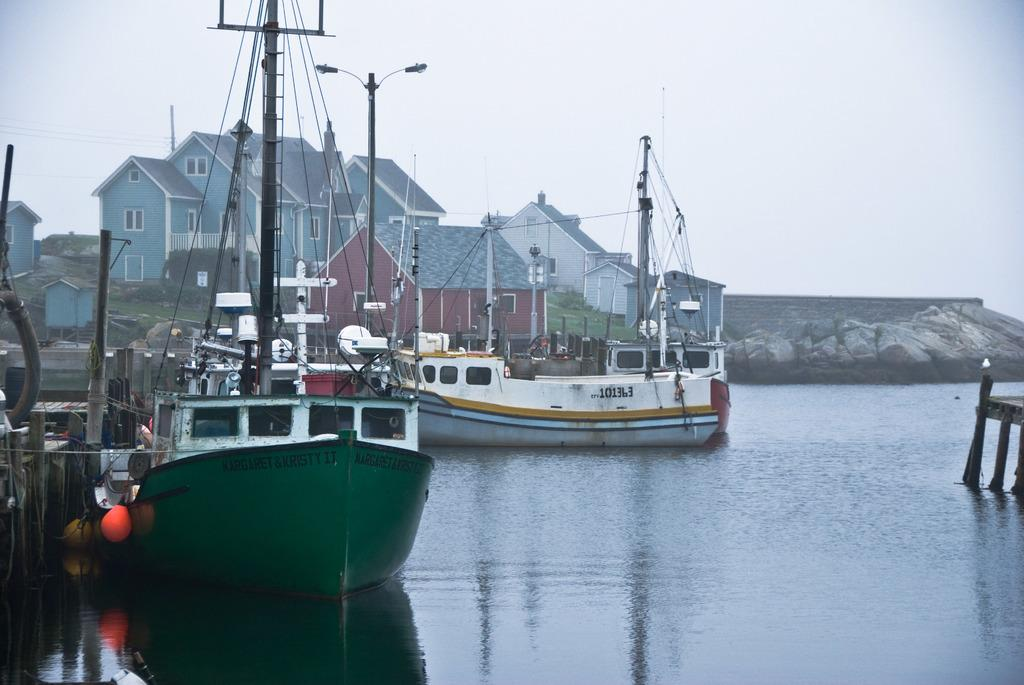What can be seen on the water in the image? There are boats on the water in the image. What structures are present in the image? There are poles, houses, and a wall in the image. What natural elements can be seen in the image? There are rocks in the image. What type of animal is visible in the image? There is a bird in the image. What else can be seen in the image besides the mentioned elements? There is an object in the image. What is visible in the background of the image? The sky is visible in the background of the image. Where is the cactus located in the image? There is no cactus present in the image. What type of boundary is visible in the image? There is no boundary mentioned or visible in the image. 